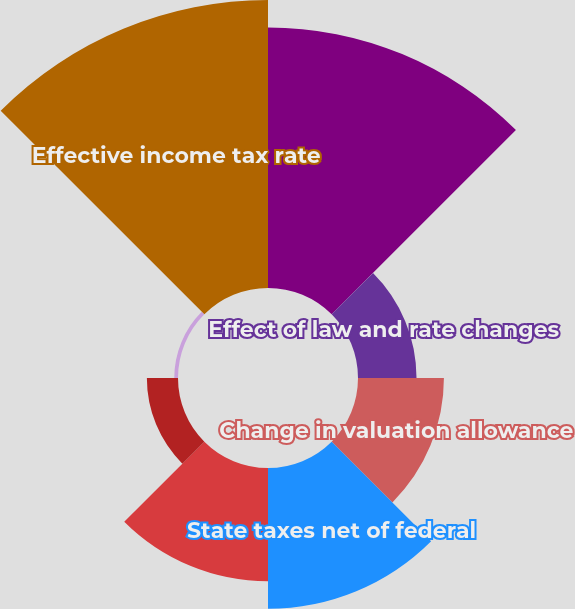Convert chart to OTSL. <chart><loc_0><loc_0><loc_500><loc_500><pie_chart><fcel>Federal statutory income tax<fcel>Effect of law and rate changes<fcel>Change in valuation allowance<fcel>State taxes net of federal<fcel>Equity-based compensation<fcel>Permanent differences<fcel>Federal tax credits net of<fcel>Effective income tax rate<nl><fcel>26.54%<fcel>5.96%<fcel>8.75%<fcel>14.33%<fcel>11.54%<fcel>3.17%<fcel>0.38%<fcel>29.33%<nl></chart> 